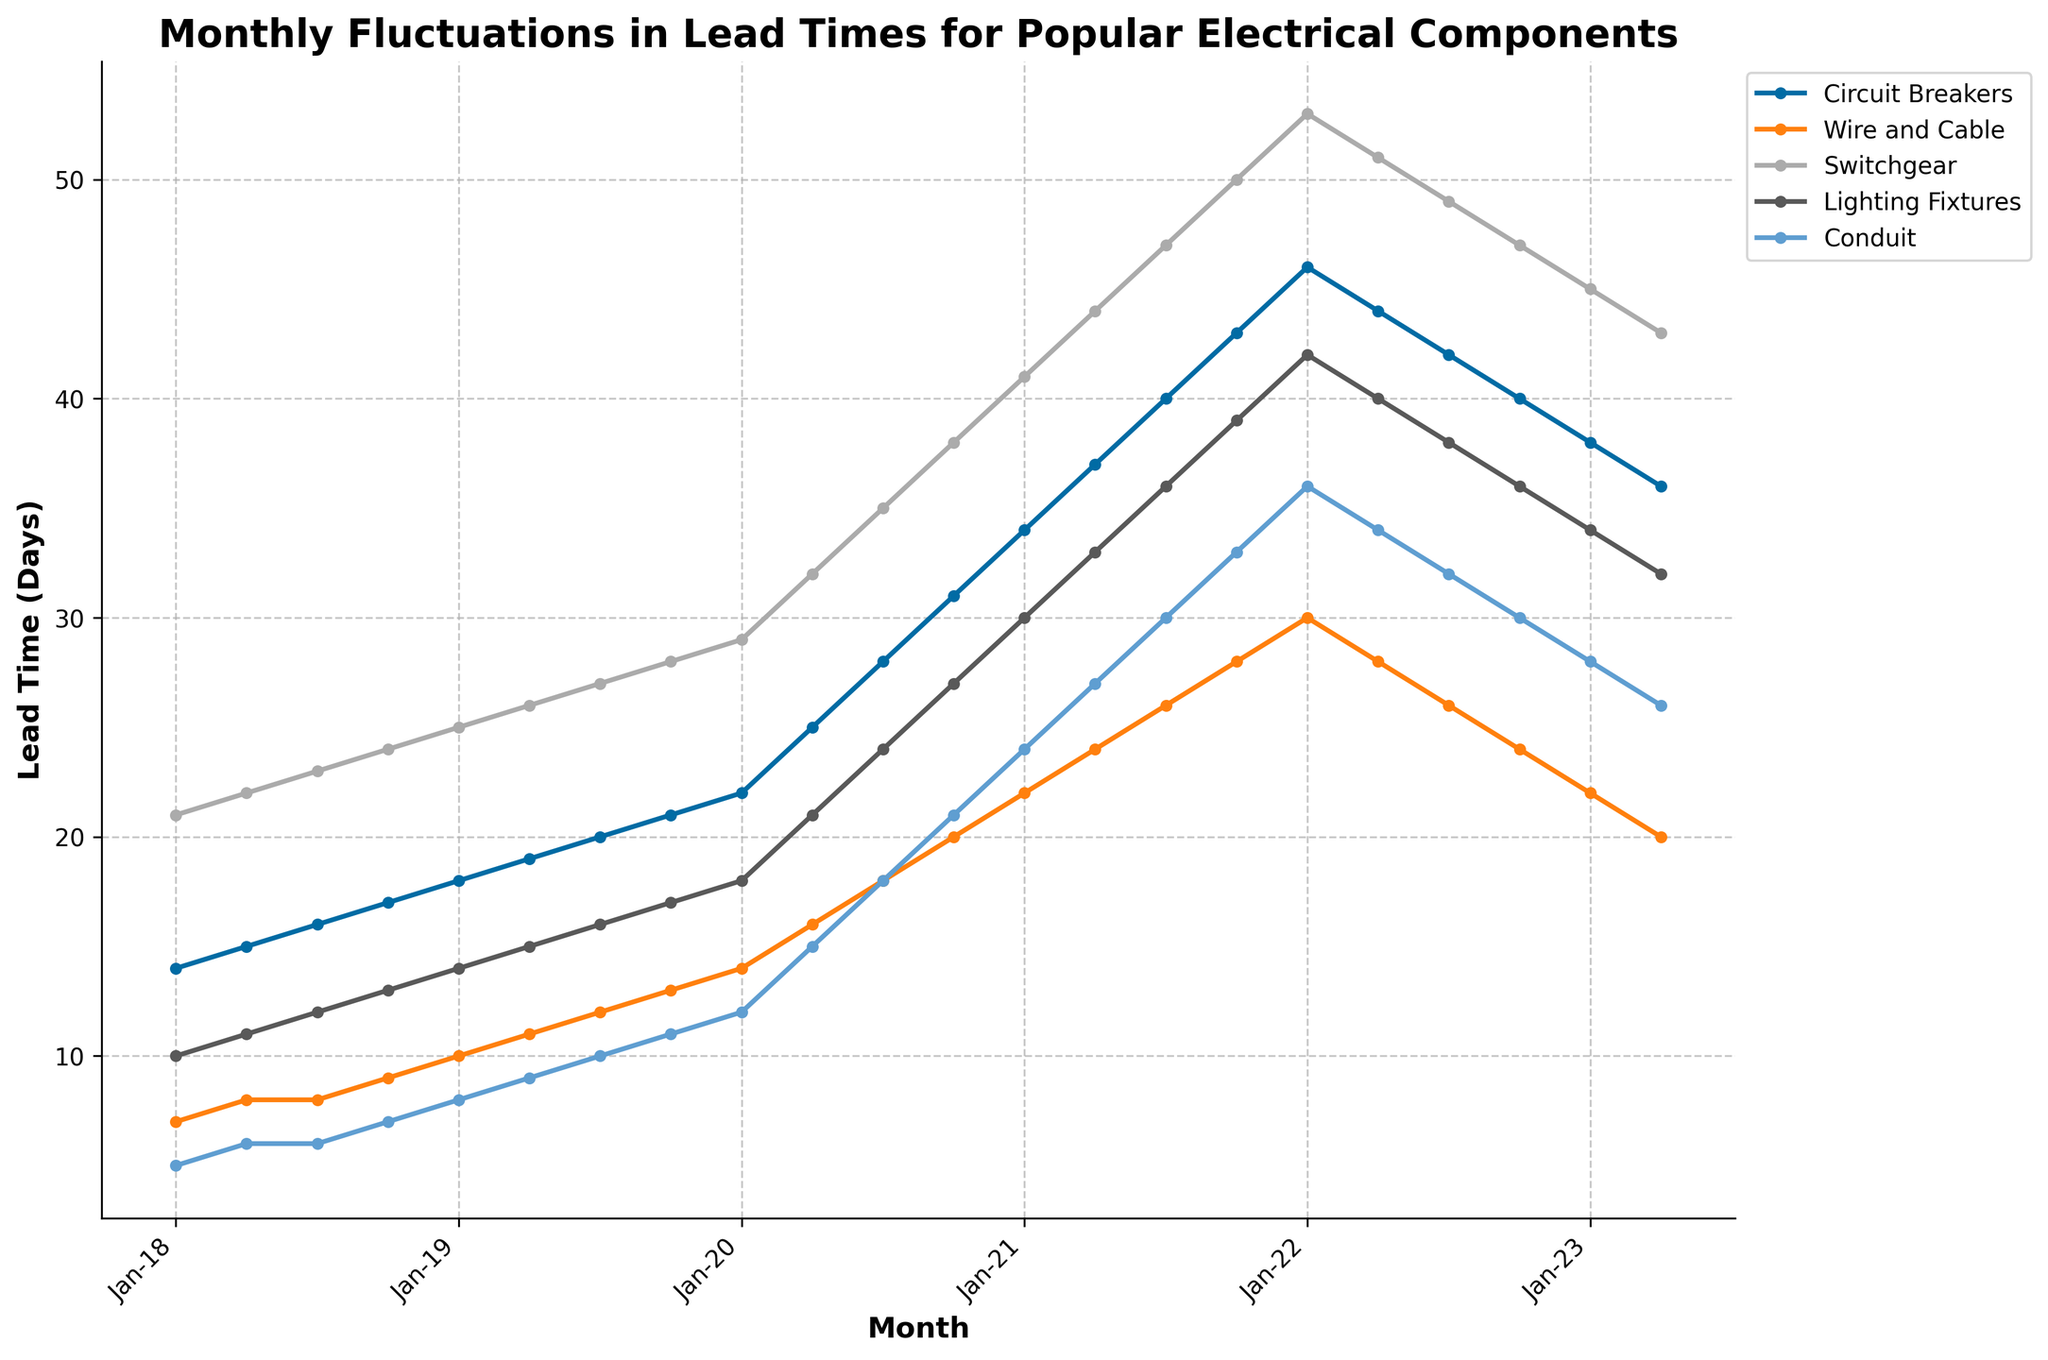What is the lead time for Wire and Cable in Jan-20? Look at the figure, find the point corresponding to Jan-20 on the x-axis, and then check the value for Wire and Cable.
Answer: 14 days Which electrical component has the highest lead time in Oct-21? Observe the points at Oct-21 on the x-axis and compare the lead times for all components. The highest point indicates the component with the highest lead time.
Answer: Switchgear How did the lead time for Conduit change from Apr-20 to Apr-21? Check the points for Conduit in Apr-20 and Apr-21 and calculate the difference between the two values.
Answer: Increased by 12 days Which component had the smallest fluctuation in lead times over the five years? Visually assess the consistency of the lines for each component. The component with the least variation in its line has the smallest fluctuation.
Answer: Wire and Cable What is the average lead time for Circuit Breakers in 2021? Identify the lead times for Circuit Breakers in Jan-21, Apr-21, Jul-21, and Oct-21. Add these values together and divide by 4 to find the average. (34 + 37 + 40 + 43) / 4 = 154 / 4
Answer: 38.5 days Compare the lead time trend for Lighting Fixtures and Conduit from Jan-22 to Apr-23. Which component showed a sharper decline? Look at the trend lines for Lighting Fixtures and Conduit from Jan-22 to Apr-23. Compare how each line declines to see which is steeper.
Answer: Conduit What is the difference in lead time between Circuit Breakers and Switchgear in Jul-20? Identify the lead times for Circuit Breakers and Switchgear in Jul-20, and then subtract the smaller value from the larger value. 35 - 28 = 7
Answer: 7 days Which component showed a decrease in lead time after Jan-22? Follow the lines for each component starting from Jan-22 and determine which ones declined.
Answer: Circuit Breakers, Wire and Cable, Switchgear, Lighting Fixtures, Conduit What is the total lead time for all components in Jan-19? Sum the lead times for all components in Jan-19. 18 + 10 + 25 + 14 + 8 = 75
Answer: 75 days Which month of 2020 had the highest overall lead time for all components combined? Sum the lead times for each component in each month of 2020 and compare the sums.
Answer: Oct-20 